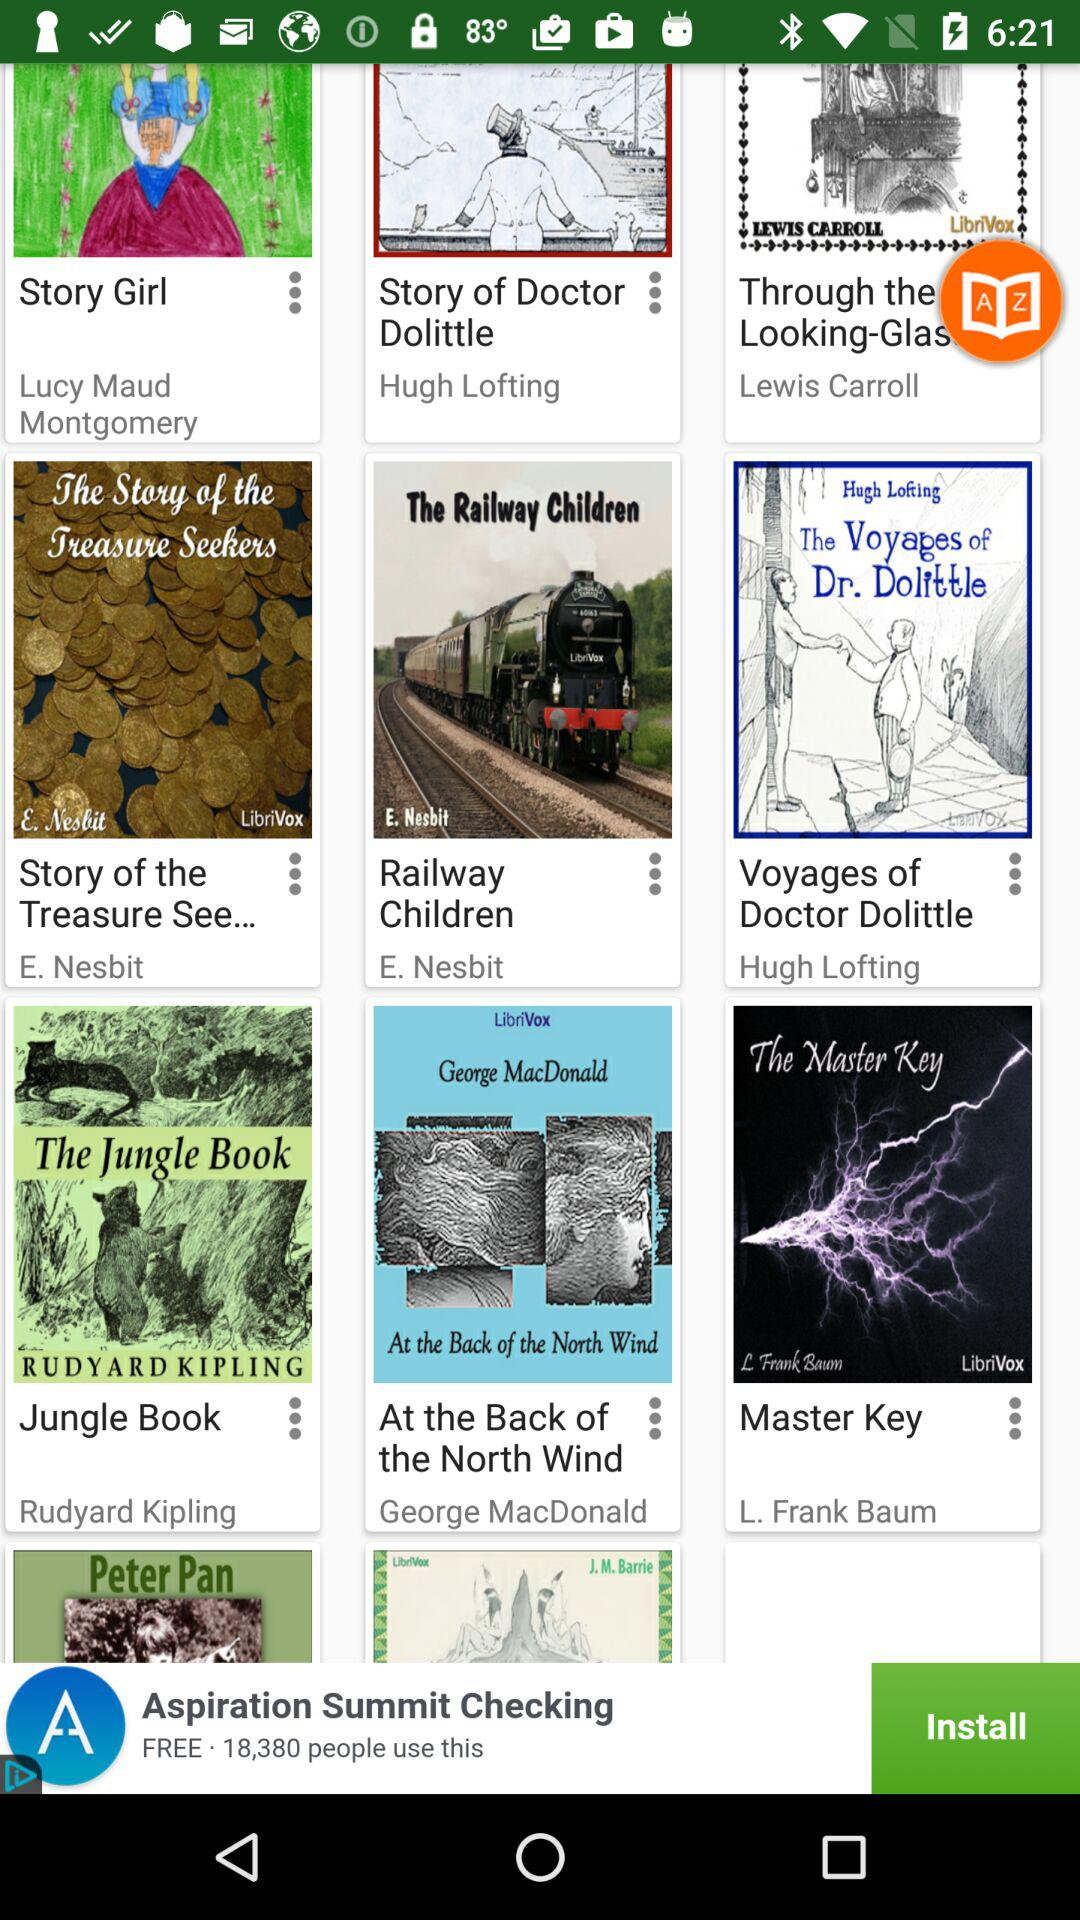Who is the author of the book "Story Girl"? The author of the book "Story Girl" is Lucy Maud Montgomery. 